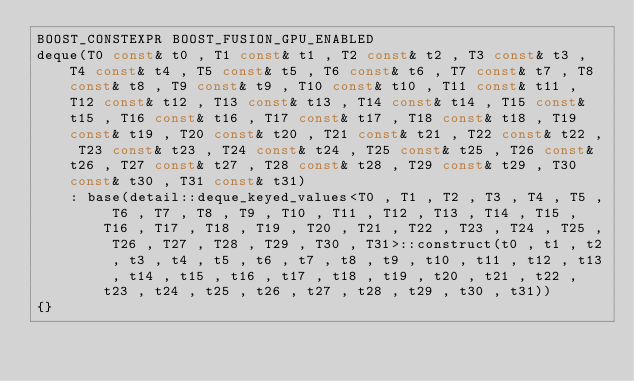<code> <loc_0><loc_0><loc_500><loc_500><_C++_>BOOST_CONSTEXPR BOOST_FUSION_GPU_ENABLED
deque(T0 const& t0 , T1 const& t1 , T2 const& t2 , T3 const& t3 , T4 const& t4 , T5 const& t5 , T6 const& t6 , T7 const& t7 , T8 const& t8 , T9 const& t9 , T10 const& t10 , T11 const& t11 , T12 const& t12 , T13 const& t13 , T14 const& t14 , T15 const& t15 , T16 const& t16 , T17 const& t17 , T18 const& t18 , T19 const& t19 , T20 const& t20 , T21 const& t21 , T22 const& t22 , T23 const& t23 , T24 const& t24 , T25 const& t25 , T26 const& t26 , T27 const& t27 , T28 const& t28 , T29 const& t29 , T30 const& t30 , T31 const& t31)
    : base(detail::deque_keyed_values<T0 , T1 , T2 , T3 , T4 , T5 , T6 , T7 , T8 , T9 , T10 , T11 , T12 , T13 , T14 , T15 , T16 , T17 , T18 , T19 , T20 , T21 , T22 , T23 , T24 , T25 , T26 , T27 , T28 , T29 , T30 , T31>::construct(t0 , t1 , t2 , t3 , t4 , t5 , t6 , t7 , t8 , t9 , t10 , t11 , t12 , t13 , t14 , t15 , t16 , t17 , t18 , t19 , t20 , t21 , t22 , t23 , t24 , t25 , t26 , t27 , t28 , t29 , t30 , t31))
{}</code> 